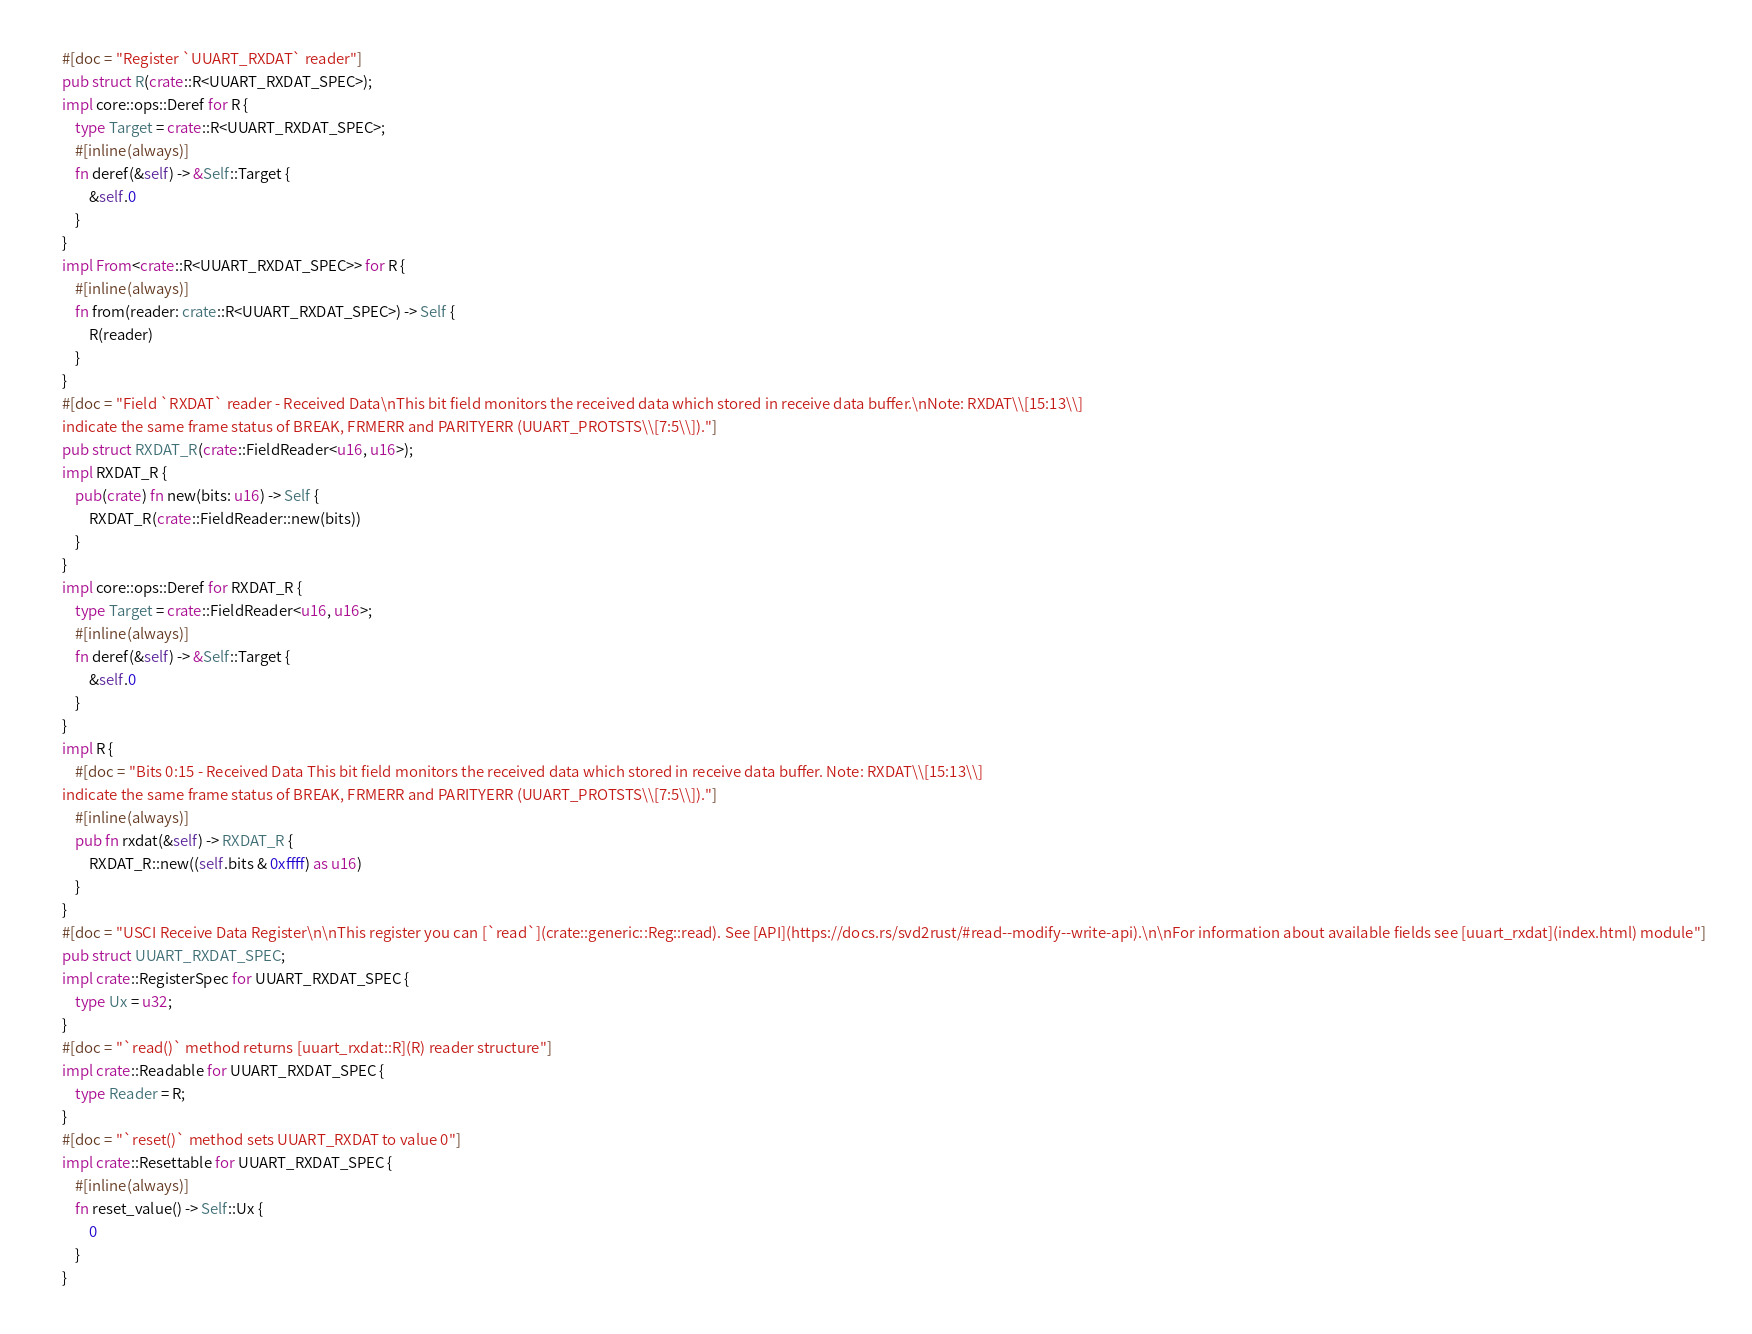Convert code to text. <code><loc_0><loc_0><loc_500><loc_500><_Rust_>#[doc = "Register `UUART_RXDAT` reader"]
pub struct R(crate::R<UUART_RXDAT_SPEC>);
impl core::ops::Deref for R {
    type Target = crate::R<UUART_RXDAT_SPEC>;
    #[inline(always)]
    fn deref(&self) -> &Self::Target {
        &self.0
    }
}
impl From<crate::R<UUART_RXDAT_SPEC>> for R {
    #[inline(always)]
    fn from(reader: crate::R<UUART_RXDAT_SPEC>) -> Self {
        R(reader)
    }
}
#[doc = "Field `RXDAT` reader - Received Data\nThis bit field monitors the received data which stored in receive data buffer.\nNote: RXDAT\\[15:13\\]
indicate the same frame status of BREAK, FRMERR and PARITYERR (UUART_PROTSTS\\[7:5\\])."]
pub struct RXDAT_R(crate::FieldReader<u16, u16>);
impl RXDAT_R {
    pub(crate) fn new(bits: u16) -> Self {
        RXDAT_R(crate::FieldReader::new(bits))
    }
}
impl core::ops::Deref for RXDAT_R {
    type Target = crate::FieldReader<u16, u16>;
    #[inline(always)]
    fn deref(&self) -> &Self::Target {
        &self.0
    }
}
impl R {
    #[doc = "Bits 0:15 - Received Data This bit field monitors the received data which stored in receive data buffer. Note: RXDAT\\[15:13\\]
indicate the same frame status of BREAK, FRMERR and PARITYERR (UUART_PROTSTS\\[7:5\\])."]
    #[inline(always)]
    pub fn rxdat(&self) -> RXDAT_R {
        RXDAT_R::new((self.bits & 0xffff) as u16)
    }
}
#[doc = "USCI Receive Data Register\n\nThis register you can [`read`](crate::generic::Reg::read). See [API](https://docs.rs/svd2rust/#read--modify--write-api).\n\nFor information about available fields see [uuart_rxdat](index.html) module"]
pub struct UUART_RXDAT_SPEC;
impl crate::RegisterSpec for UUART_RXDAT_SPEC {
    type Ux = u32;
}
#[doc = "`read()` method returns [uuart_rxdat::R](R) reader structure"]
impl crate::Readable for UUART_RXDAT_SPEC {
    type Reader = R;
}
#[doc = "`reset()` method sets UUART_RXDAT to value 0"]
impl crate::Resettable for UUART_RXDAT_SPEC {
    #[inline(always)]
    fn reset_value() -> Self::Ux {
        0
    }
}
</code> 